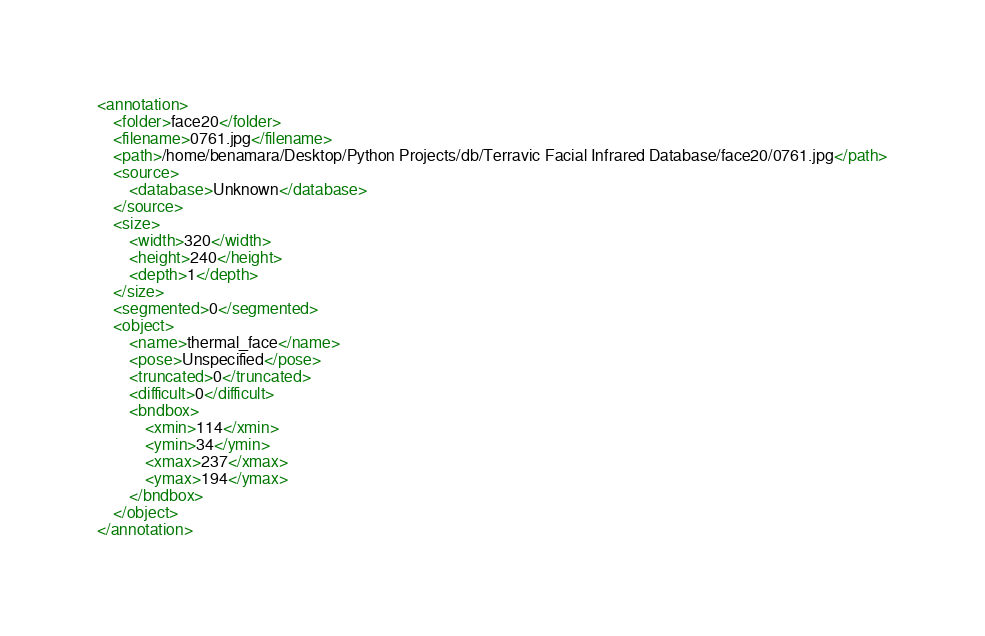<code> <loc_0><loc_0><loc_500><loc_500><_XML_><annotation>
	<folder>face20</folder>
	<filename>0761.jpg</filename>
	<path>/home/benamara/Desktop/Python Projects/db/Terravic Facial Infrared Database/face20/0761.jpg</path>
	<source>
		<database>Unknown</database>
	</source>
	<size>
		<width>320</width>
		<height>240</height>
		<depth>1</depth>
	</size>
	<segmented>0</segmented>
	<object>
		<name>thermal_face</name>
		<pose>Unspecified</pose>
		<truncated>0</truncated>
		<difficult>0</difficult>
		<bndbox>
			<xmin>114</xmin>
			<ymin>34</ymin>
			<xmax>237</xmax>
			<ymax>194</ymax>
		</bndbox>
	</object>
</annotation>
</code> 